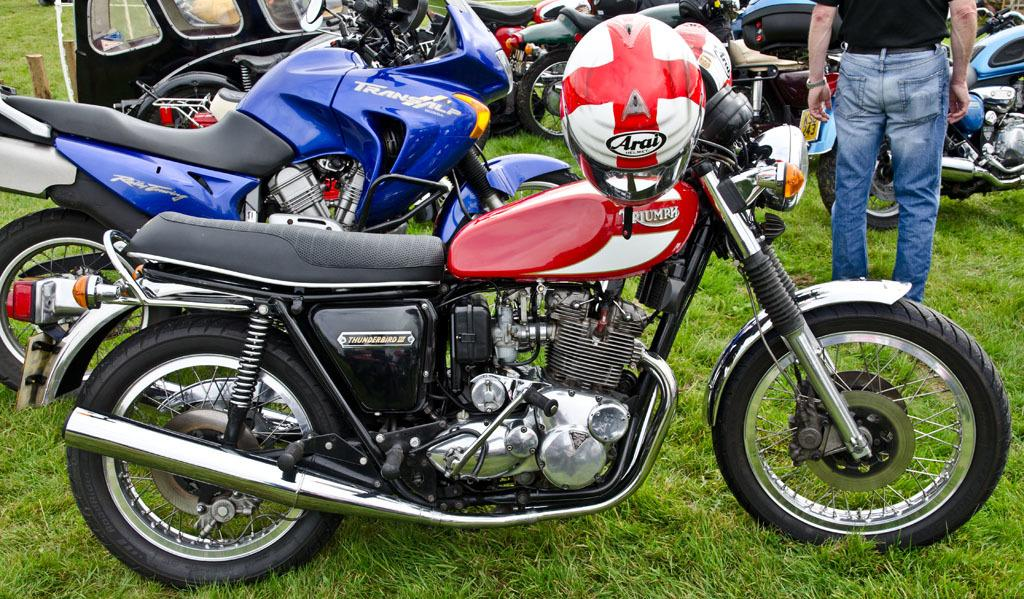What type of vehicles are in the image? There are motorcycles in the image. Can you describe the person in the image? There is a person on the ground in the image. What color is the person's vest in the image? There is no mention of a vest in the image, so we cannot determine its color. 